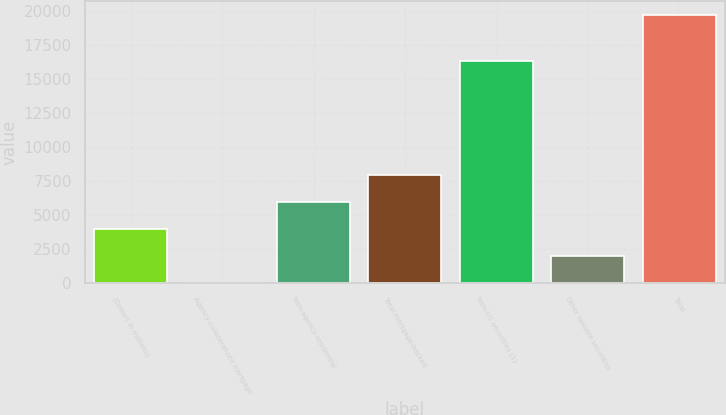Convert chart. <chart><loc_0><loc_0><loc_500><loc_500><bar_chart><fcel>(Dollars in millions)<fcel>Agency-collateralized mortgage<fcel>Non-agency residential<fcel>Total mortgage-backed<fcel>Non-US securities (1)<fcel>Other taxable securities<fcel>Total<nl><fcel>3948<fcel>5<fcel>5919.5<fcel>7891<fcel>16336<fcel>1976.5<fcel>19720<nl></chart> 